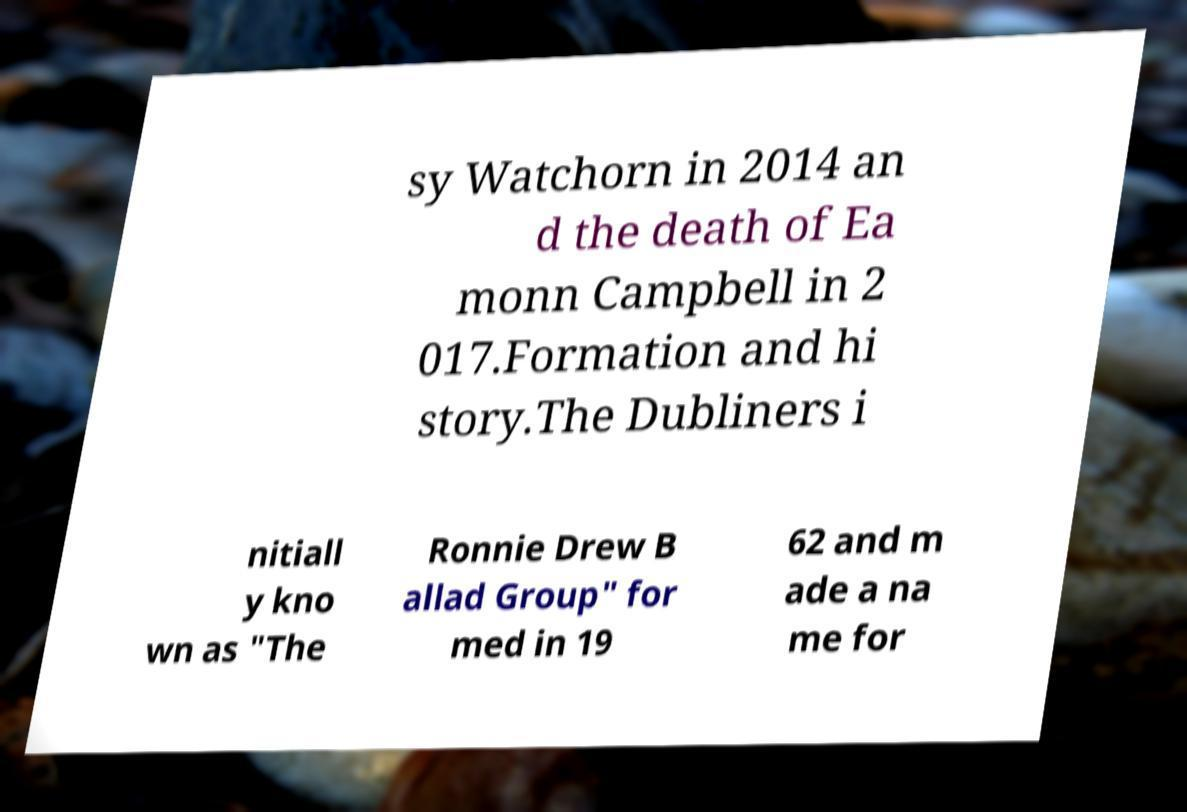What messages or text are displayed in this image? I need them in a readable, typed format. sy Watchorn in 2014 an d the death of Ea monn Campbell in 2 017.Formation and hi story.The Dubliners i nitiall y kno wn as "The Ronnie Drew B allad Group" for med in 19 62 and m ade a na me for 